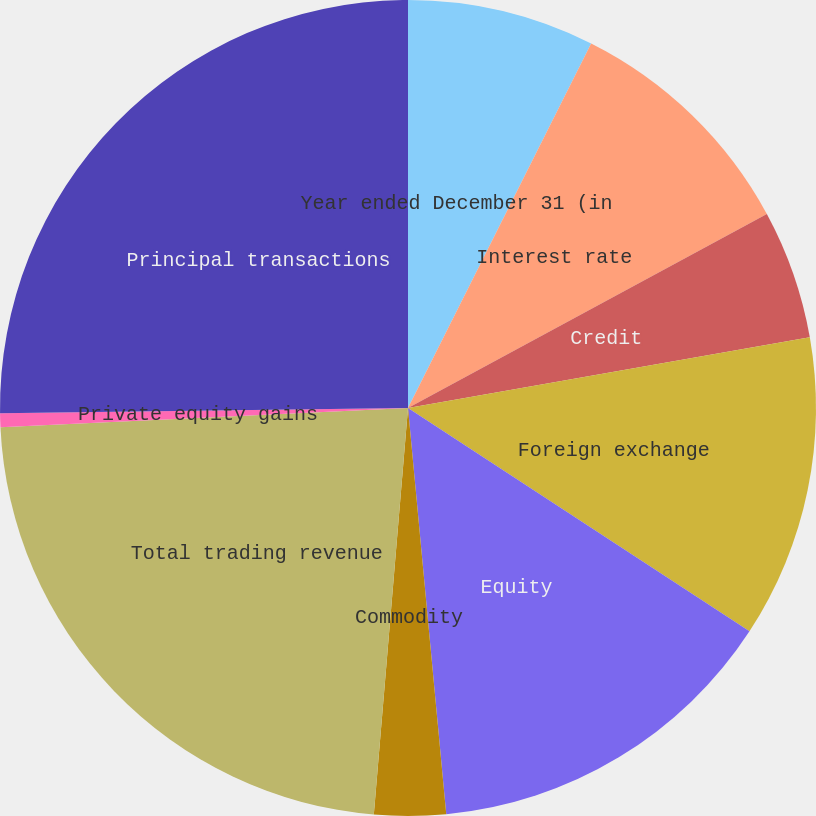<chart> <loc_0><loc_0><loc_500><loc_500><pie_chart><fcel>Year ended December 31 (in<fcel>Interest rate<fcel>Credit<fcel>Foreign exchange<fcel>Equity<fcel>Commodity<fcel>Total trading revenue<fcel>Private equity gains<fcel>Principal transactions<nl><fcel>7.41%<fcel>9.7%<fcel>5.12%<fcel>11.99%<fcel>14.29%<fcel>2.83%<fcel>22.92%<fcel>0.54%<fcel>25.21%<nl></chart> 